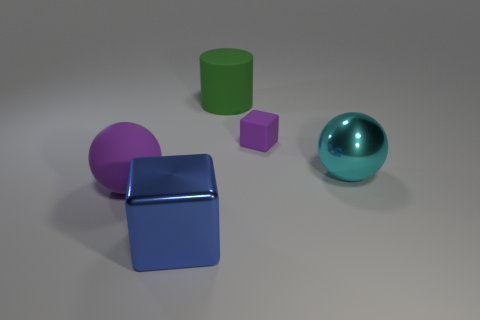Is there any other thing that has the same shape as the large green matte object?
Ensure brevity in your answer.  No. What number of cylinders have the same material as the cyan thing?
Keep it short and to the point. 0. How many objects are large shiny things that are left of the big metal sphere or purple rubber objects?
Provide a short and direct response. 3. Are there fewer blue metal cubes behind the large cylinder than large green matte cylinders left of the cyan metal sphere?
Provide a short and direct response. Yes. Are there any big blue metal cubes in front of the rubber sphere?
Offer a very short reply. Yes. What number of things are balls to the left of the blue shiny object or balls that are right of the green object?
Ensure brevity in your answer.  2. What number of rubber balls have the same color as the tiny matte thing?
Your response must be concise. 1. There is another matte object that is the same shape as the big blue object; what color is it?
Offer a very short reply. Purple. The object that is both in front of the tiny object and on the right side of the green rubber thing has what shape?
Give a very brief answer. Sphere. Is the number of big objects greater than the number of large blue balls?
Provide a short and direct response. Yes. 